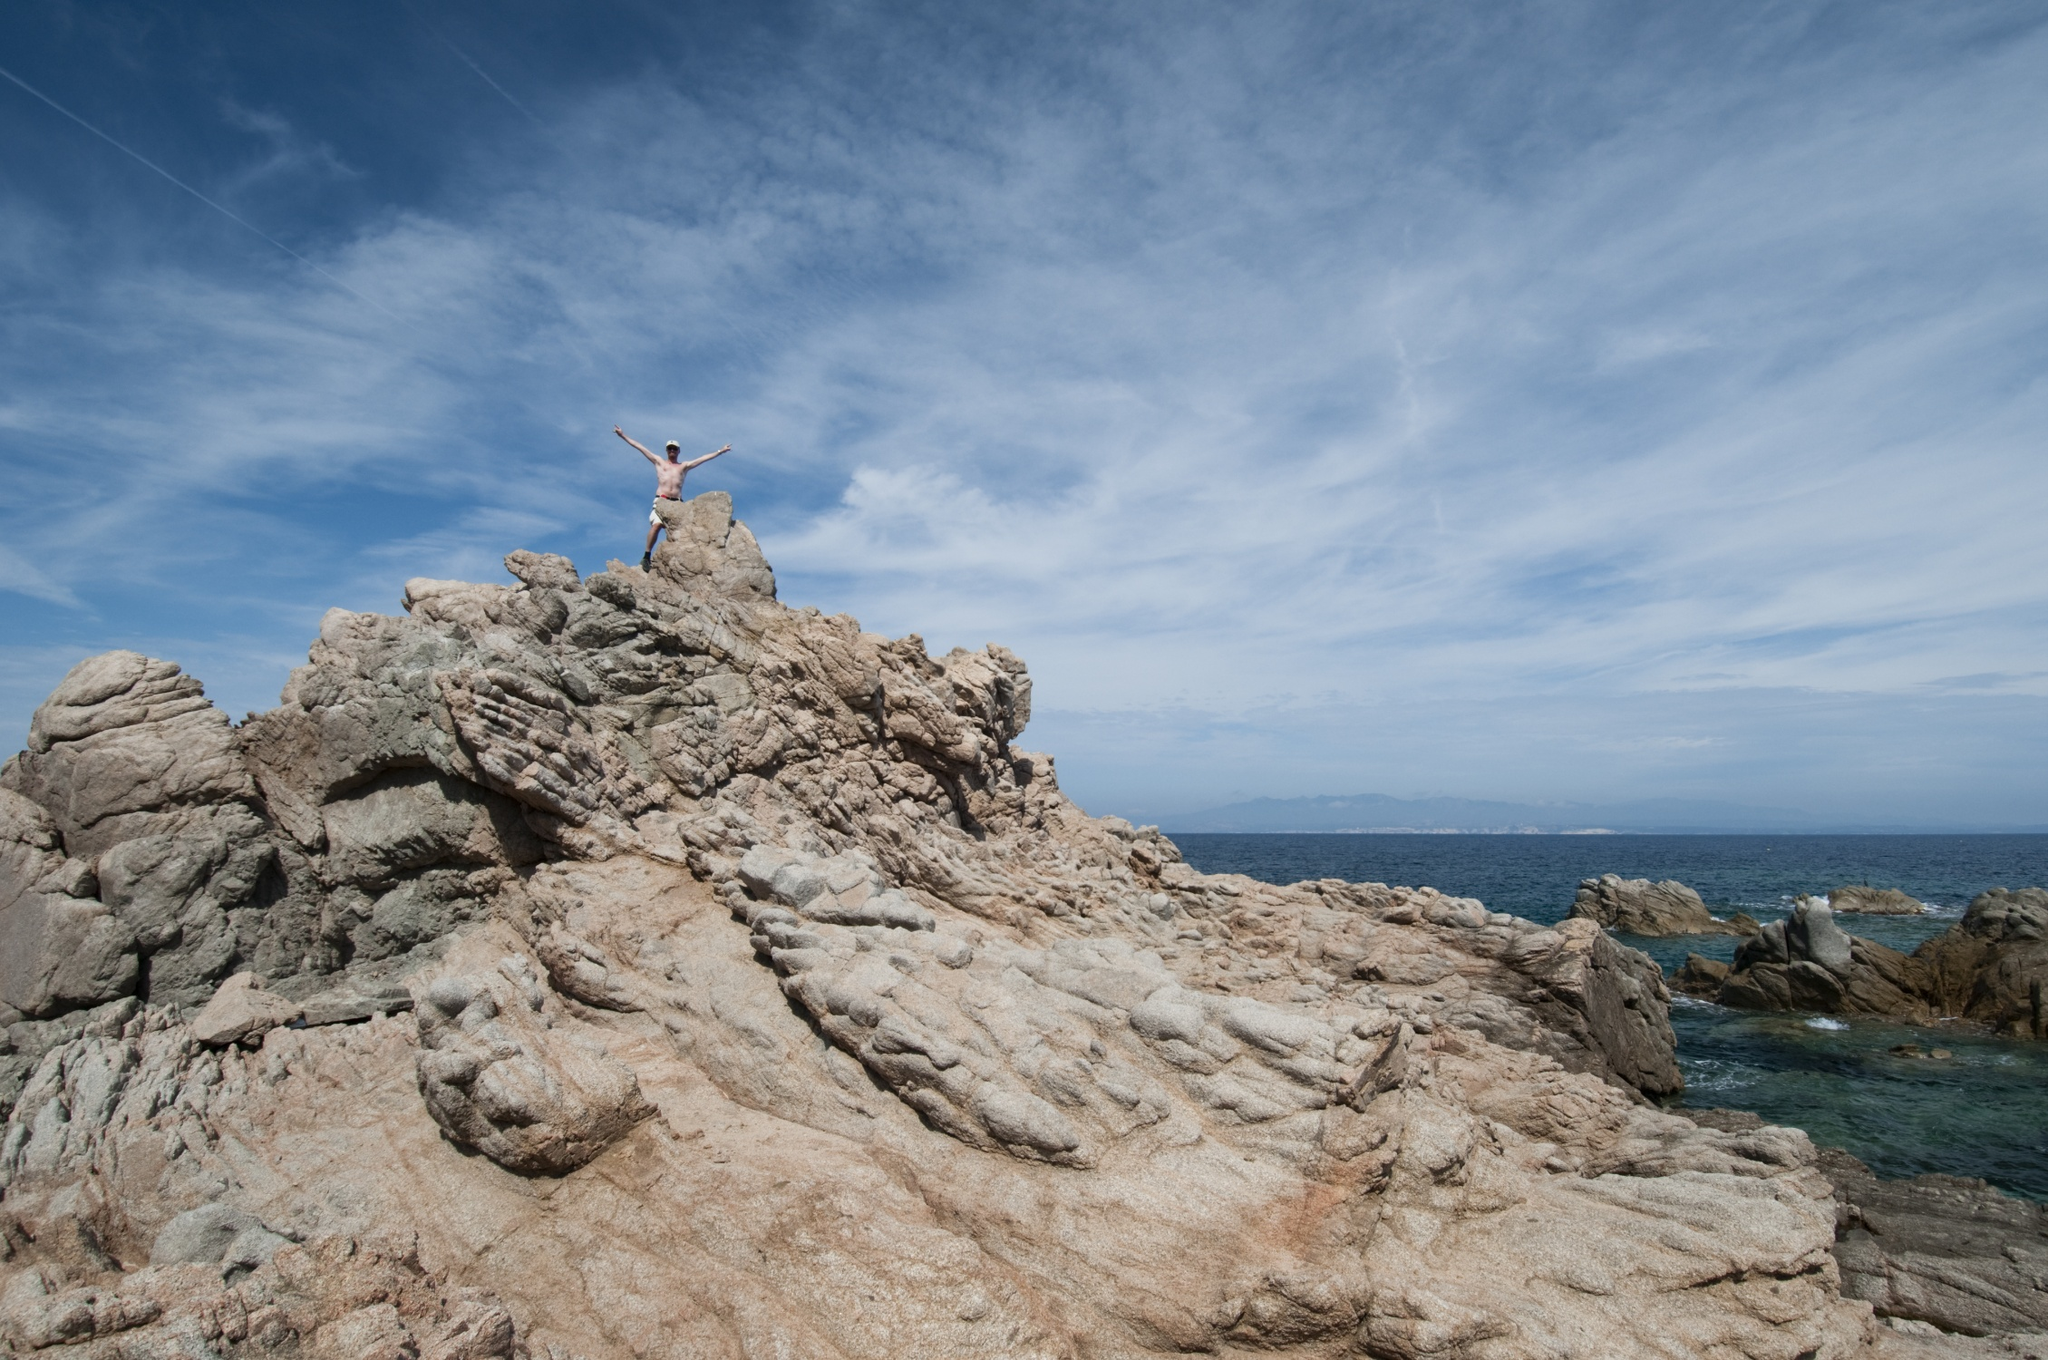Imagine a story set in this location. What could be the background of the person standing on the cliff? Once upon a time, there was an adventurer named Alex who had always been drawn to the sea. After months of grueling training and preparation, Alex set out on a solo expedition to explore remote coastal territories. The journey was filled with challenges, from navigating through unpredictable weather to climbing treacherous cliffs. This moment, captured in the image, represents the culmination of Alex's journey, standing triumphant at the peak, overlooking the vast ocean, symbolizing the achievement of a lifelong dream. It's a tale of perseverance, exploration, and the human spirit's unyielding quest for discovery. 